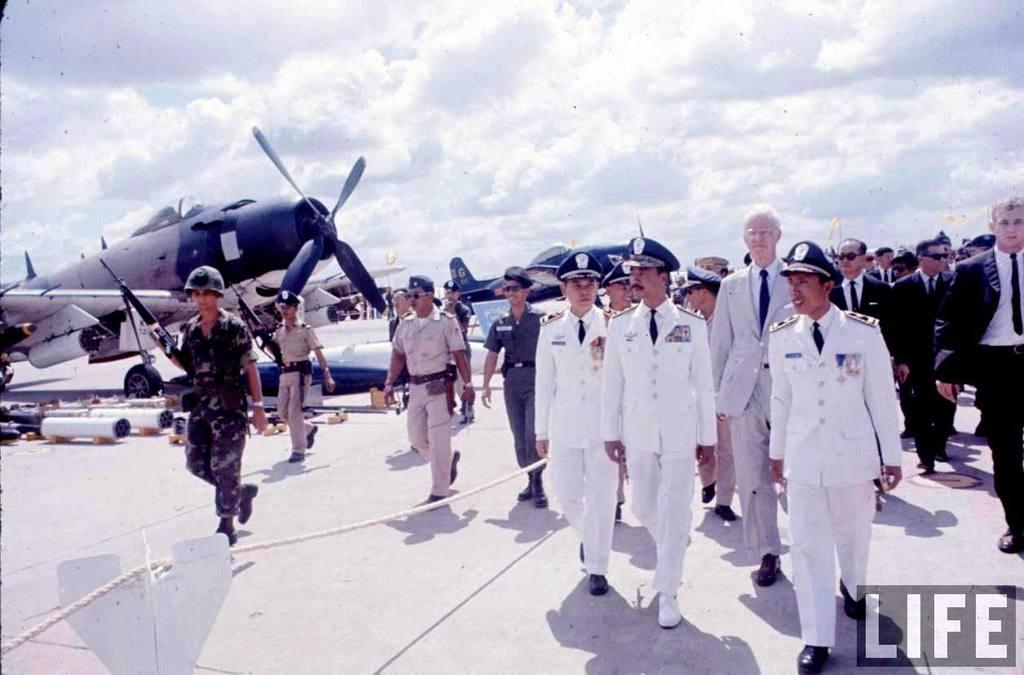What can be seen in the image? There are persons standing in the image. Where are the planes located in the image? The planes are in the left corner of the image. What is written in the image? There is text written in the right bottom corner of the image. How would you describe the sky in the image? The sky is cloudy in the image. Are the image? There is no indication in the image that the persons or planes are biting anything. Can you tell if the persons in the image are angry? There is no visible expression or context to determine if the persons in the image are angry. 